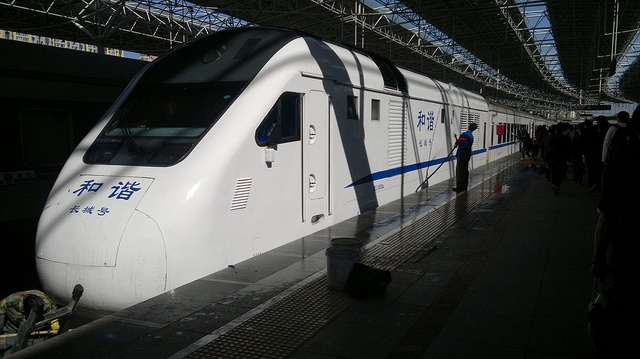Describe the objects in this image and their specific colors. I can see train in black, lightgray, darkgray, and gray tones, people in black and gray tones, people in black tones, people in black and gray tones, and people in black, navy, gray, and darkgray tones in this image. 